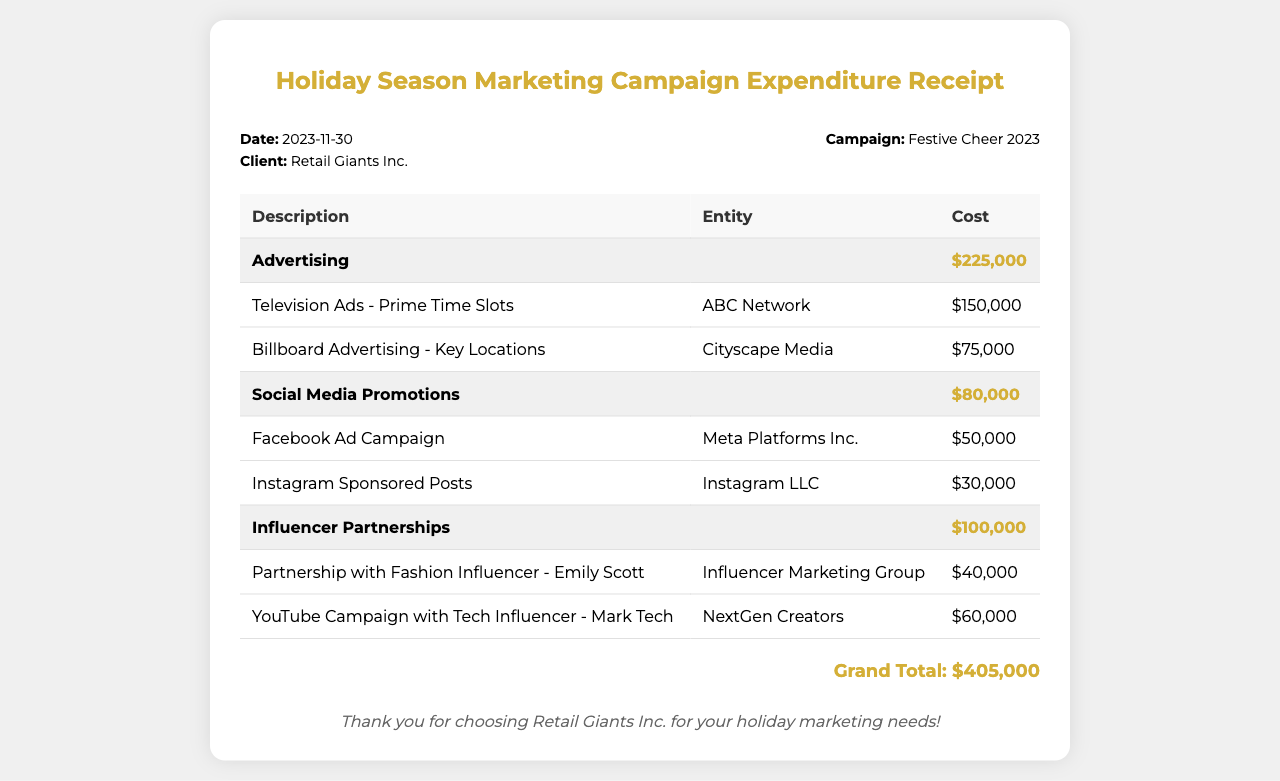What is the date of the receipt? The receipt states the date at the top, which is 2023-11-30.
Answer: 2023-11-30 Who is the client mentioned in the receipt? The client is identified in the document as Retail Giants Inc.
Answer: Retail Giants Inc What is the total cost for Advertising? The total cost for Advertising is clearly mentioned in a separate row, which is $225,000.
Answer: $225,000 What is the cost of the Television Ads? The Television Ads cost is listed individually in the table, which is $150,000.
Answer: $150,000 How much was spent on Influencer Partnerships? The document provides a total for Influencer Partnerships, which is $100,000.
Answer: $100,000 What is the grand total of the marketing campaign expenditure? The grand total is summarized at the bottom of the document as $405,000.
Answer: $405,000 Which entity provided the Billboard Advertising? The entity associated with Billboard Advertising is mentioned as Cityscape Media.
Answer: Cityscape Media What is the cost for Instagram Sponsored Posts? The Instagram Sponsored Posts are outlined in the table with a cost of $30,000.
Answer: $30,000 What is the purpose of the notes at the bottom? The notes express gratitude for choosing Retail Giants Inc. for holiday marketing needs, serving a customer service purpose.
Answer: Thank you for choosing Retail Giants Inc. for your holiday marketing needs! 